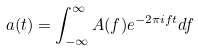<formula> <loc_0><loc_0><loc_500><loc_500>a ( t ) = \int ^ { \infty } _ { - \infty } A ( f ) e ^ { - 2 \pi i f t } d f</formula> 